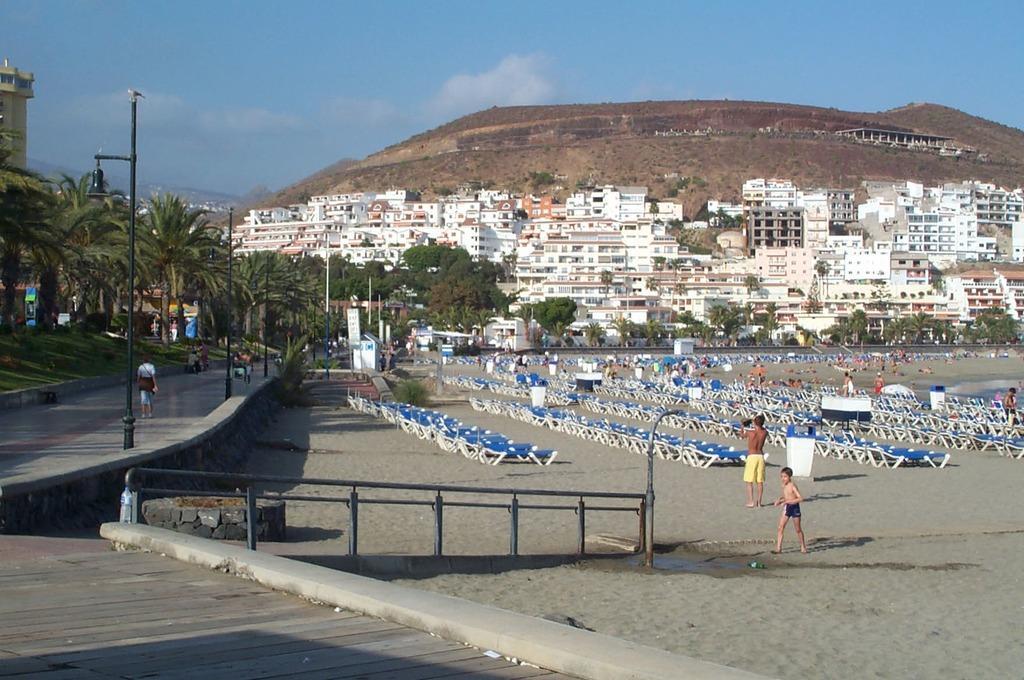Describe this image in one or two sentences. In the picture we can see a sand surface on it we can see some people are walking and we can see branches which are blue in color and near to it we can see a wall and path and some poles on it and we can also see some trees and in the background we can see house buildings and behind it we can see a hill and some construction on it and behind it we can see a sky. 